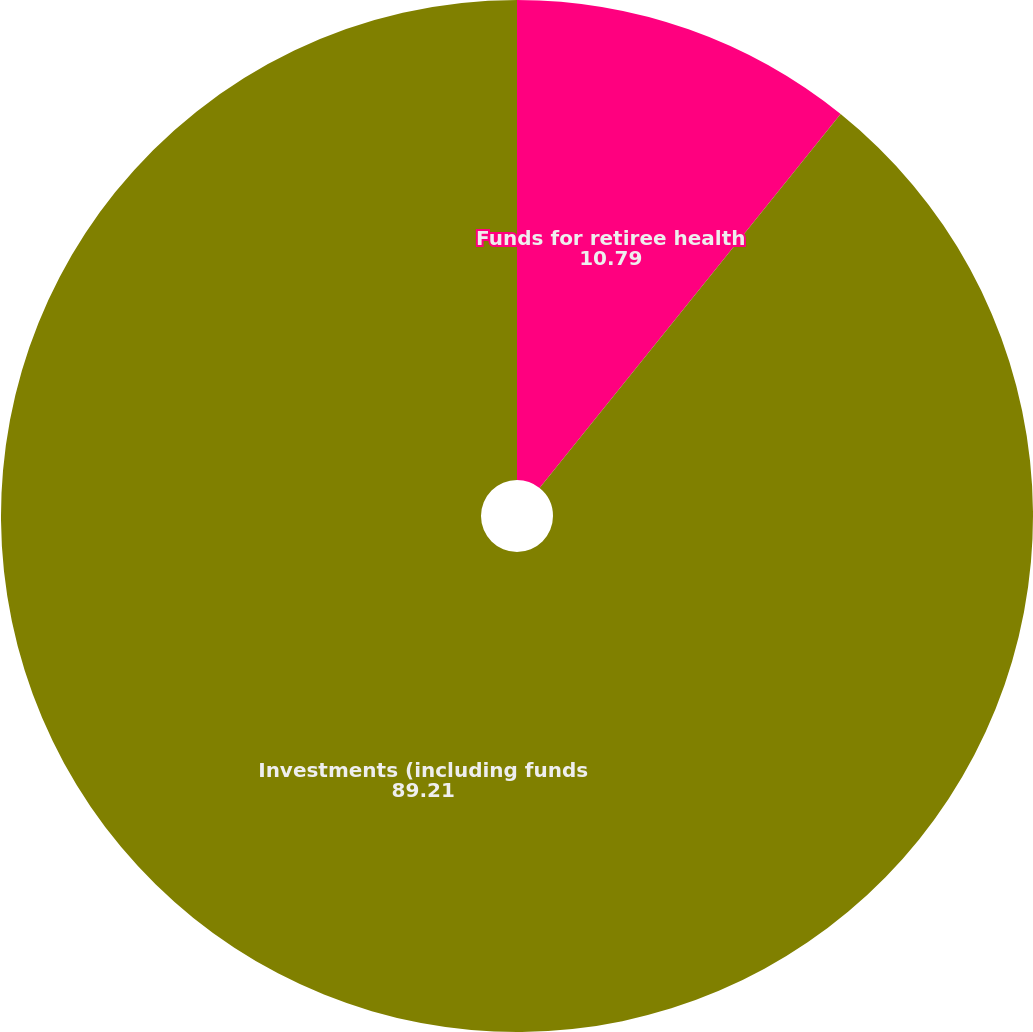<chart> <loc_0><loc_0><loc_500><loc_500><pie_chart><fcel>Funds for retiree health<fcel>Investments (including funds<nl><fcel>10.79%<fcel>89.21%<nl></chart> 